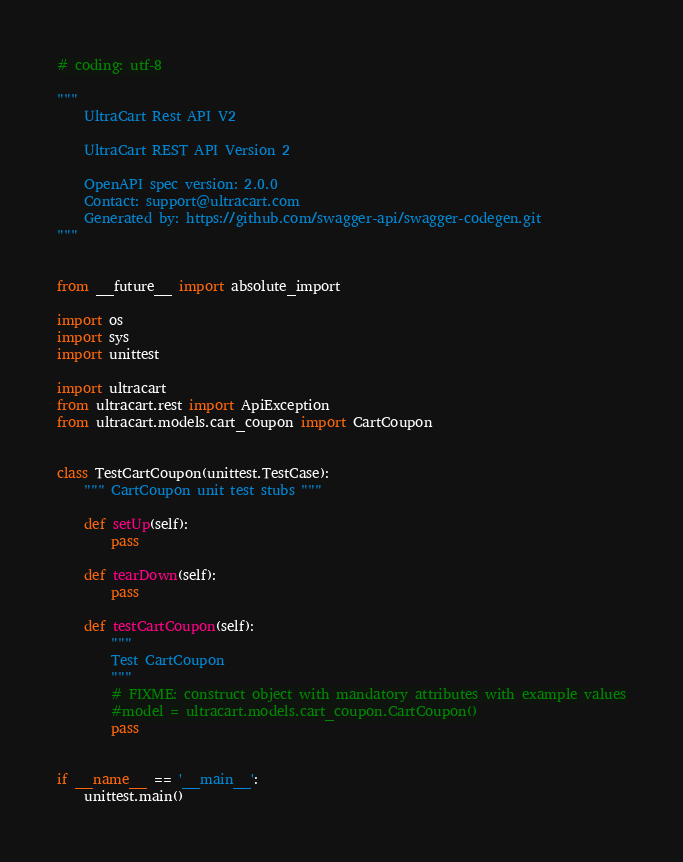<code> <loc_0><loc_0><loc_500><loc_500><_Python_># coding: utf-8

"""
    UltraCart Rest API V2

    UltraCart REST API Version 2

    OpenAPI spec version: 2.0.0
    Contact: support@ultracart.com
    Generated by: https://github.com/swagger-api/swagger-codegen.git
"""


from __future__ import absolute_import

import os
import sys
import unittest

import ultracart
from ultracart.rest import ApiException
from ultracart.models.cart_coupon import CartCoupon


class TestCartCoupon(unittest.TestCase):
    """ CartCoupon unit test stubs """

    def setUp(self):
        pass

    def tearDown(self):
        pass

    def testCartCoupon(self):
        """
        Test CartCoupon
        """
        # FIXME: construct object with mandatory attributes with example values
        #model = ultracart.models.cart_coupon.CartCoupon()
        pass


if __name__ == '__main__':
    unittest.main()
</code> 